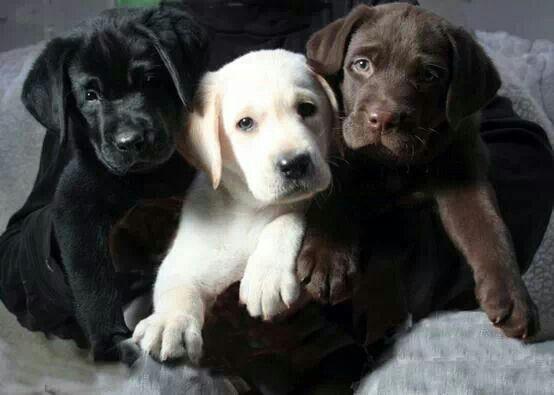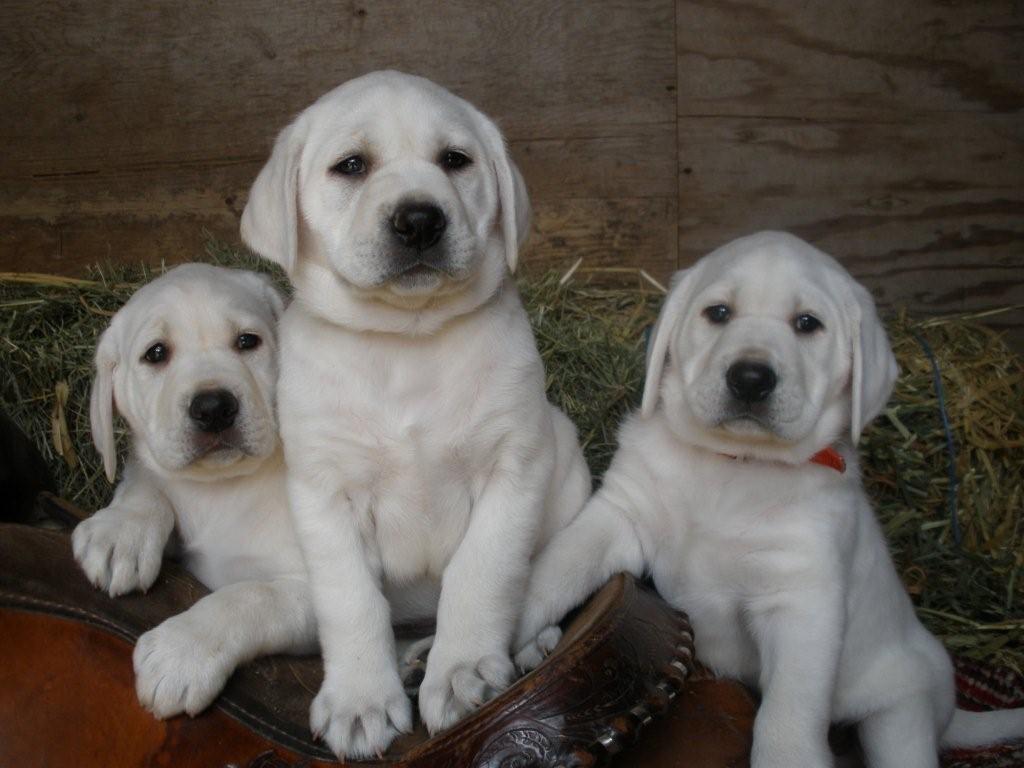The first image is the image on the left, the second image is the image on the right. For the images displayed, is the sentence "Both images contain exactly three dogs, and include at least one image of all different colored dogs." factually correct? Answer yes or no. Yes. The first image is the image on the left, the second image is the image on the right. Examine the images to the left and right. Is the description "There are three labs posing together in each image." accurate? Answer yes or no. Yes. 